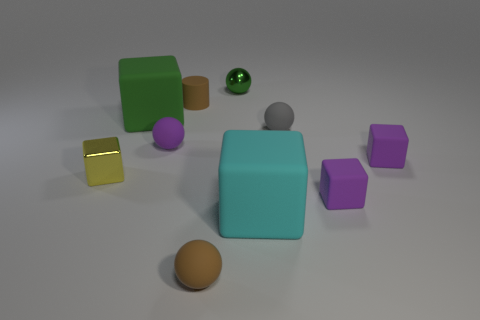Subtract all green matte blocks. How many blocks are left? 4 Subtract all brown balls. How many balls are left? 3 Subtract all cylinders. How many objects are left? 9 Subtract 4 cubes. How many cubes are left? 1 Subtract all blue spheres. How many blue cubes are left? 0 Subtract all gray shiny cylinders. Subtract all big green blocks. How many objects are left? 9 Add 6 large objects. How many large objects are left? 8 Add 8 big red shiny things. How many big red shiny things exist? 8 Subtract 0 cyan balls. How many objects are left? 10 Subtract all brown cubes. Subtract all red cylinders. How many cubes are left? 5 